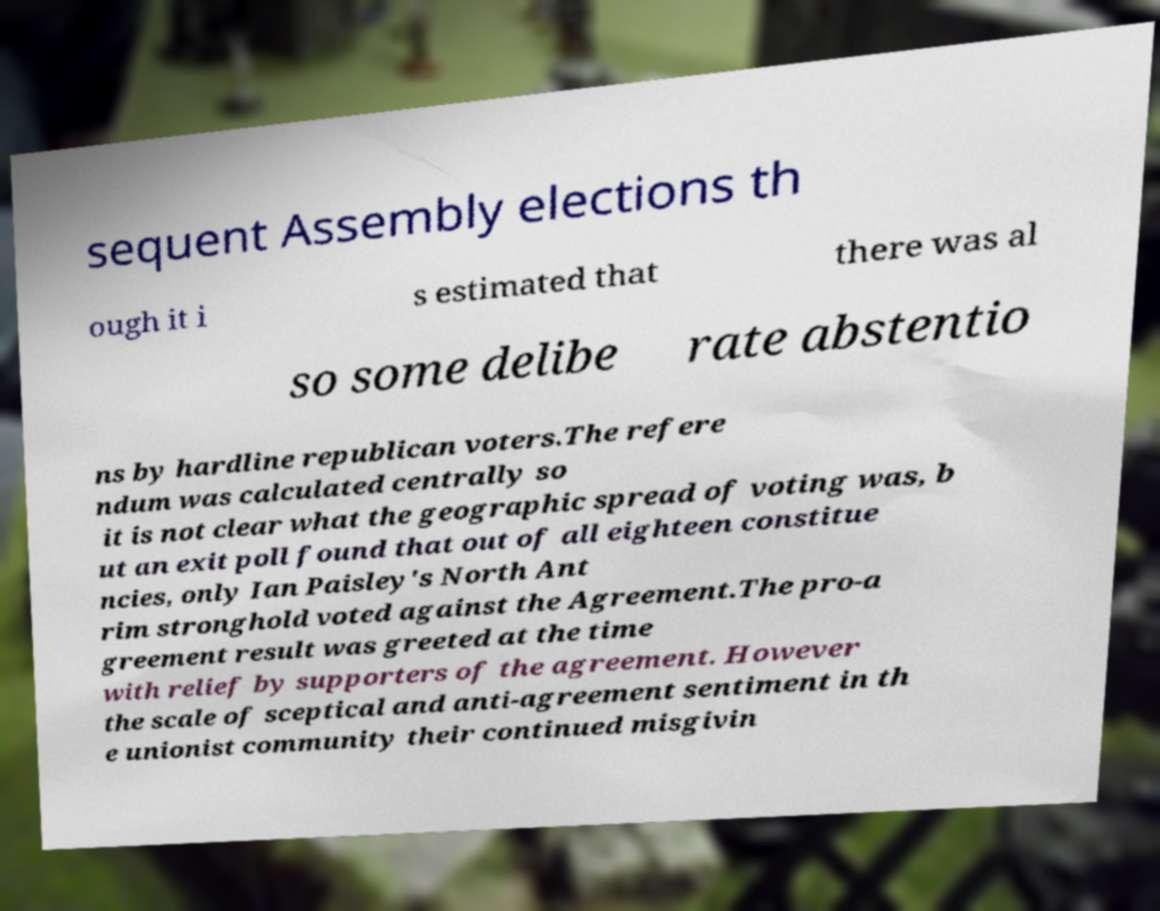Please identify and transcribe the text found in this image. sequent Assembly elections th ough it i s estimated that there was al so some delibe rate abstentio ns by hardline republican voters.The refere ndum was calculated centrally so it is not clear what the geographic spread of voting was, b ut an exit poll found that out of all eighteen constitue ncies, only Ian Paisley's North Ant rim stronghold voted against the Agreement.The pro-a greement result was greeted at the time with relief by supporters of the agreement. However the scale of sceptical and anti-agreement sentiment in th e unionist community their continued misgivin 